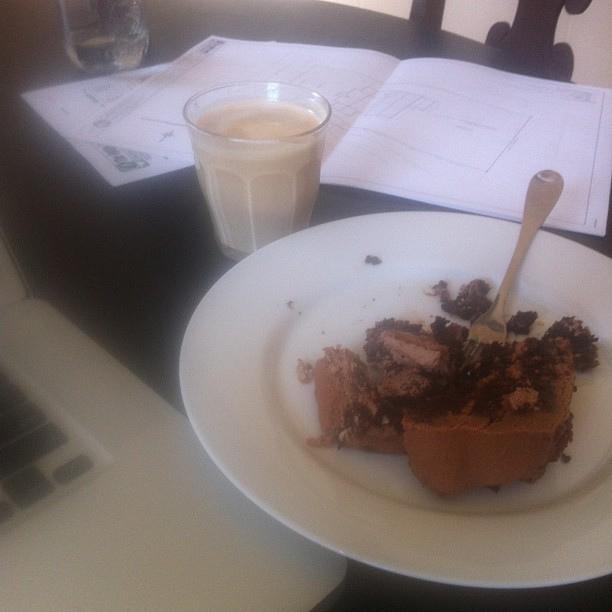Has any of the meal been eaten?
Be succinct. Yes. What kind of silverware is shown?
Quick response, please. Fork. What is in the plate?
Give a very brief answer. Cake. What type of food is on the plate?
Quick response, please. Cake. What color is the plate?
Be succinct. White. What is the person doing while they eat?
Answer briefly. Reading. What color is the rim?
Short answer required. White. How many forks are shown?
Quick response, please. 1. What type of utensils are pictured?
Be succinct. Fork. How many silverware are on the plate?
Answer briefly. 1. Is this a glazed donut?
Quick response, please. No. What is the food on?
Concise answer only. Plate. What is the bowl sitting on?
Concise answer only. Table. Would you like to have a snack like that?
Write a very short answer. Yes. Is there ice in the glass?
Give a very brief answer. No. What kind of food is half eaten on the plate?
Concise answer only. Cake. Is the fork broken?
Quick response, please. No. What shape is the cup?
Write a very short answer. Round. What is in the middle of the plate?
Give a very brief answer. Cake. Is that a sandwich?
Write a very short answer. No. What is in the cup?
Be succinct. Milk. What kind of leaf is on the desert?
Be succinct. None. 